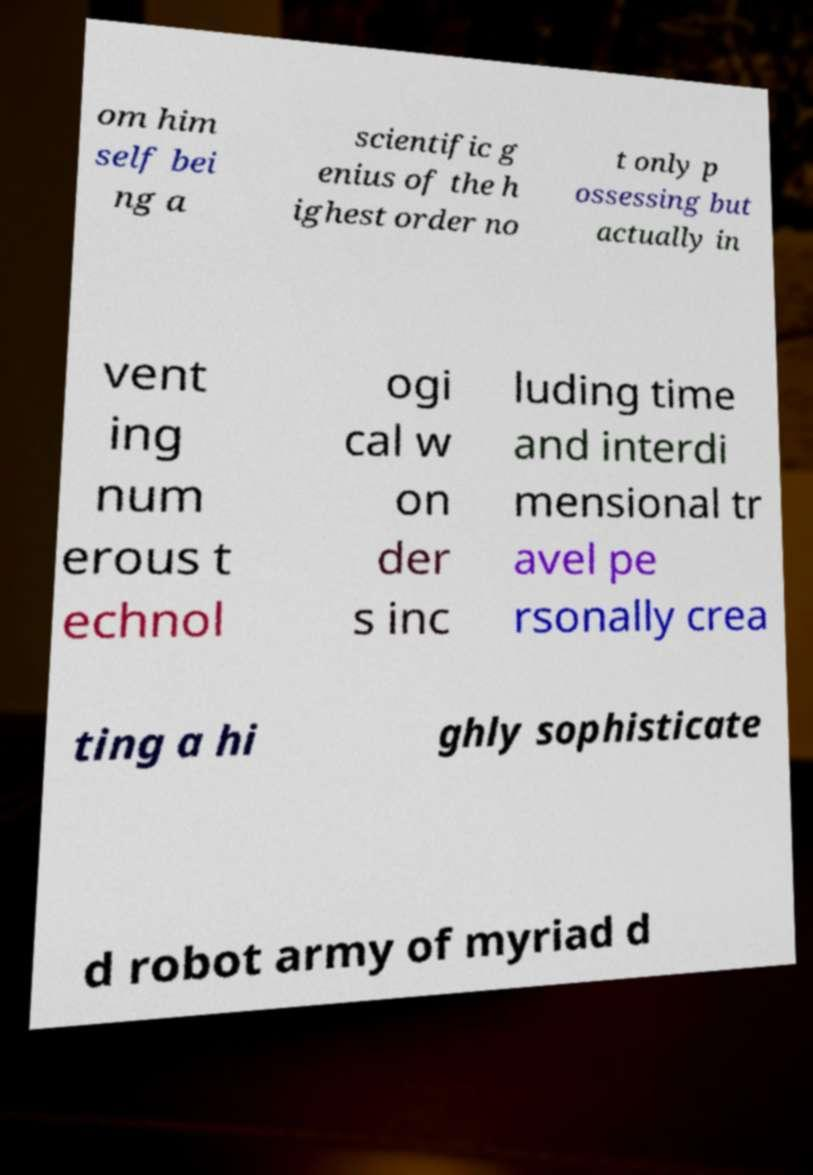Can you accurately transcribe the text from the provided image for me? om him self bei ng a scientific g enius of the h ighest order no t only p ossessing but actually in vent ing num erous t echnol ogi cal w on der s inc luding time and interdi mensional tr avel pe rsonally crea ting a hi ghly sophisticate d robot army of myriad d 